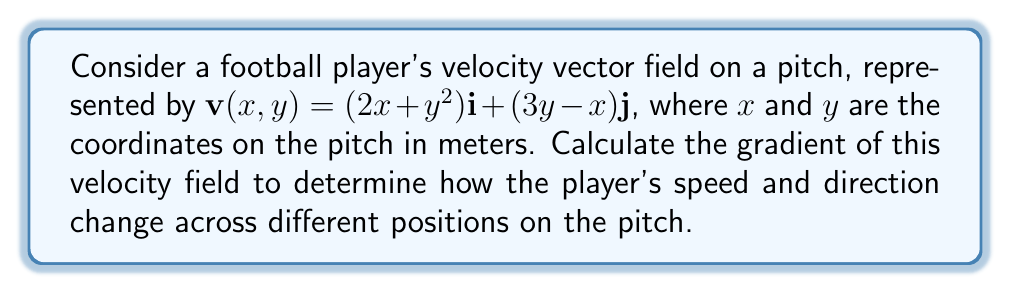Provide a solution to this math problem. To solve this problem, we need to follow these steps:

1. Recall the definition of the gradient for a vector field in 2D:
   For a vector field $\mathbf{F}(x, y) = P(x,y)\mathbf{i} + Q(x,y)\mathbf{j}$, the gradient is:
   
   $$\nabla \mathbf{F} = \begin{bmatrix}
   \frac{\partial P}{\partial x} & \frac{\partial P}{\partial y} \\
   \frac{\partial Q}{\partial x} & \frac{\partial Q}{\partial y}
   \end{bmatrix}$$

2. Identify the components of our velocity vector field:
   $P(x,y) = 2x + y^2$
   $Q(x,y) = 3y - x$

3. Calculate the partial derivatives:
   $\frac{\partial P}{\partial x} = 2$
   $\frac{\partial P}{\partial y} = 2y$
   $\frac{\partial Q}{\partial x} = -1$
   $\frac{\partial Q}{\partial y} = 3$

4. Construct the gradient matrix:
   $$\nabla \mathbf{v} = \begin{bmatrix}
   2 & 2y \\
   -1 & 3
   \end{bmatrix}$$

This gradient matrix represents how the player's velocity changes with respect to position on the pitch. Each element provides information about the rate of change of velocity components in different directions:

- The element (1,1) shows that the x-component of velocity increases at a constant rate of 2 in the x-direction.
- The element (1,2) indicates that the x-component of velocity increases quadratically with y.
- The element (2,1) shows that the y-component of velocity decreases linearly with x.
- The element (2,2) indicates that the y-component of velocity increases at a constant rate of 3 in the y-direction.
Answer: $$\nabla \mathbf{v} = \begin{bmatrix}
2 & 2y \\
-1 & 3
\end{bmatrix}$$ 